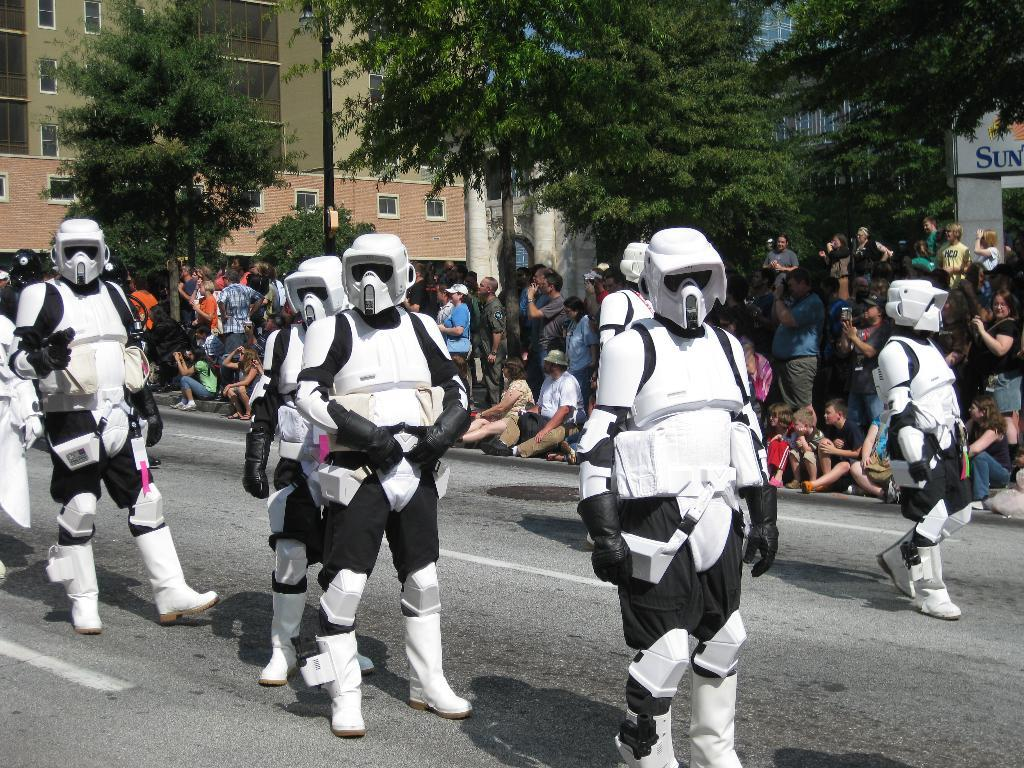What are the persons in the image wearing? The persons in the image are wearing white and black costumes, gloves, helmets, and boots. Where are the persons located in the image? The persons are on the road in the image. What can be seen in the background of the image? There are many people, a light pole, and a building with windows in the background of the image. What type of flower can be seen growing on the light pole in the image? There is no flower growing on the light pole in the image. What are the persons learning while wearing their costumes in the image? The image does not provide information about what the persons might be learning while wearing their costumes. 